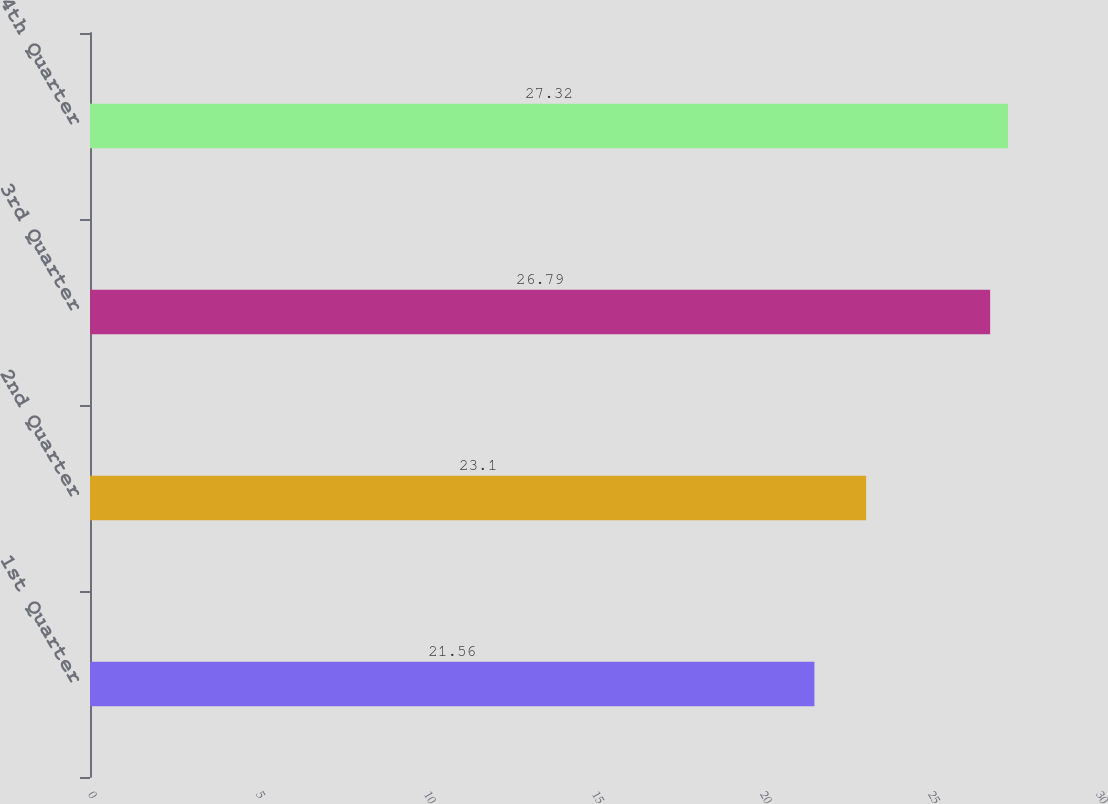Convert chart to OTSL. <chart><loc_0><loc_0><loc_500><loc_500><bar_chart><fcel>1st Quarter<fcel>2nd Quarter<fcel>3rd Quarter<fcel>4th Quarter<nl><fcel>21.56<fcel>23.1<fcel>26.79<fcel>27.32<nl></chart> 